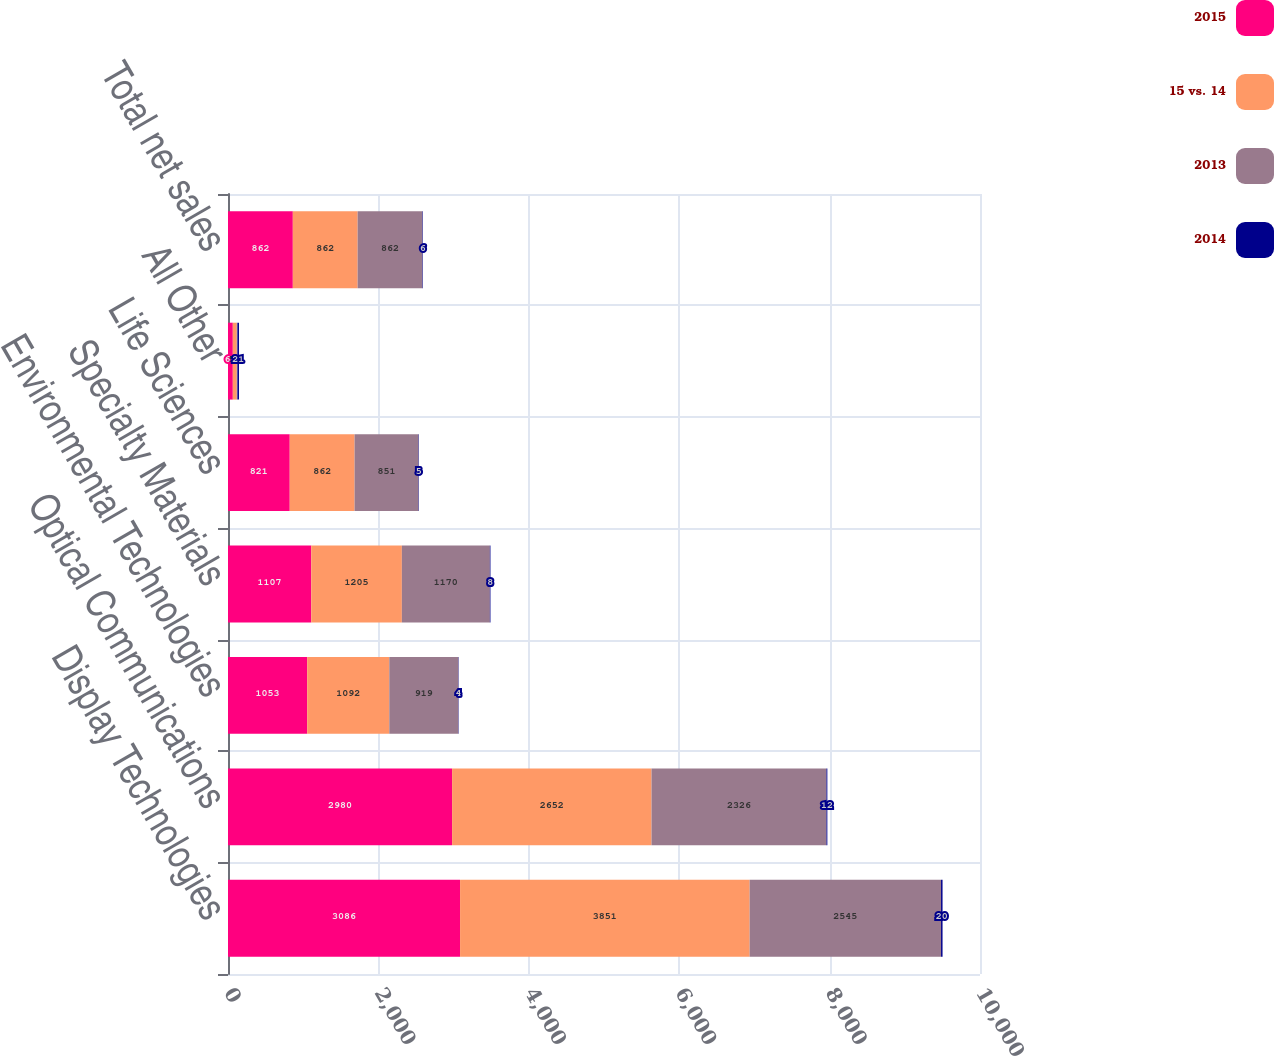Convert chart. <chart><loc_0><loc_0><loc_500><loc_500><stacked_bar_chart><ecel><fcel>Display Technologies<fcel>Optical Communications<fcel>Environmental Technologies<fcel>Specialty Materials<fcel>Life Sciences<fcel>All Other<fcel>Total net sales<nl><fcel>2015<fcel>3086<fcel>2980<fcel>1053<fcel>1107<fcel>821<fcel>64<fcel>862<nl><fcel>15 vs. 14<fcel>3851<fcel>2652<fcel>1092<fcel>1205<fcel>862<fcel>53<fcel>862<nl><fcel>2013<fcel>2545<fcel>2326<fcel>919<fcel>1170<fcel>851<fcel>8<fcel>862<nl><fcel>2014<fcel>20<fcel>12<fcel>4<fcel>8<fcel>5<fcel>21<fcel>6<nl></chart> 